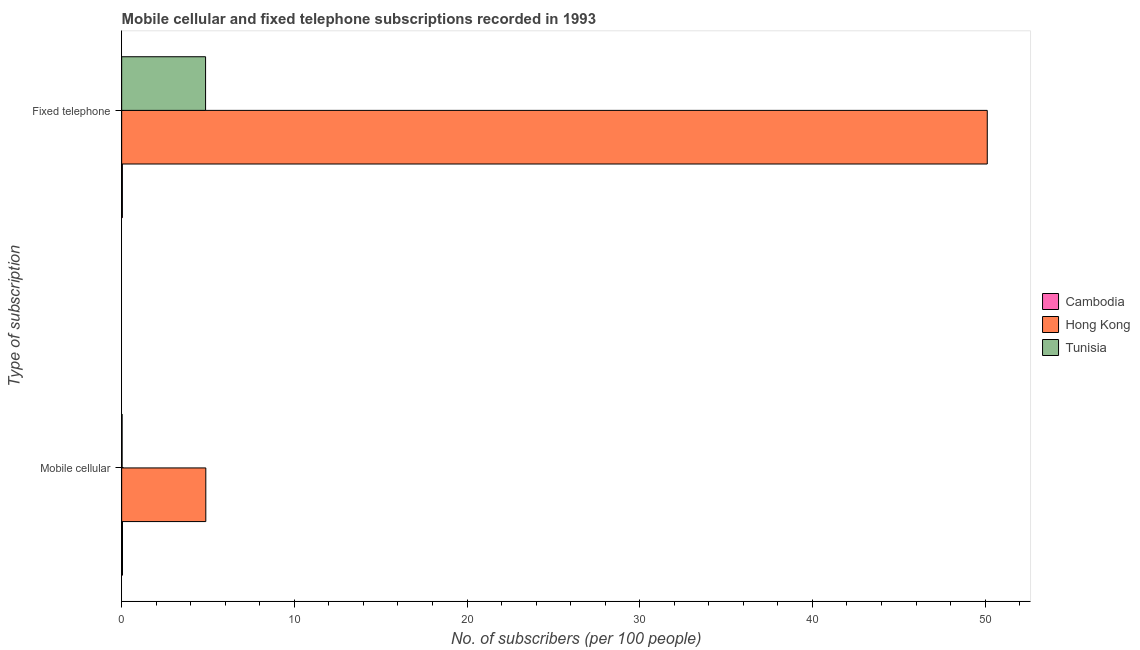How many different coloured bars are there?
Offer a terse response. 3. How many groups of bars are there?
Provide a short and direct response. 2. Are the number of bars per tick equal to the number of legend labels?
Make the answer very short. Yes. Are the number of bars on each tick of the Y-axis equal?
Offer a terse response. Yes. What is the label of the 2nd group of bars from the top?
Give a very brief answer. Mobile cellular. What is the number of mobile cellular subscribers in Hong Kong?
Give a very brief answer. 4.87. Across all countries, what is the maximum number of fixed telephone subscribers?
Keep it short and to the point. 50.12. Across all countries, what is the minimum number of fixed telephone subscribers?
Keep it short and to the point. 0.04. In which country was the number of fixed telephone subscribers maximum?
Ensure brevity in your answer.  Hong Kong. In which country was the number of mobile cellular subscribers minimum?
Keep it short and to the point. Tunisia. What is the total number of fixed telephone subscribers in the graph?
Offer a terse response. 55.02. What is the difference between the number of mobile cellular subscribers in Hong Kong and that in Cambodia?
Provide a short and direct response. 4.82. What is the difference between the number of fixed telephone subscribers in Cambodia and the number of mobile cellular subscribers in Tunisia?
Your answer should be compact. 0.02. What is the average number of fixed telephone subscribers per country?
Your answer should be very brief. 18.34. What is the difference between the number of fixed telephone subscribers and number of mobile cellular subscribers in Hong Kong?
Keep it short and to the point. 45.25. In how many countries, is the number of mobile cellular subscribers greater than 18 ?
Your answer should be very brief. 0. What is the ratio of the number of fixed telephone subscribers in Hong Kong to that in Tunisia?
Offer a very short reply. 10.32. Is the number of fixed telephone subscribers in Cambodia less than that in Hong Kong?
Offer a terse response. Yes. In how many countries, is the number of mobile cellular subscribers greater than the average number of mobile cellular subscribers taken over all countries?
Ensure brevity in your answer.  1. What does the 1st bar from the top in Mobile cellular represents?
Ensure brevity in your answer.  Tunisia. What does the 2nd bar from the bottom in Mobile cellular represents?
Give a very brief answer. Hong Kong. Are all the bars in the graph horizontal?
Keep it short and to the point. Yes. What is the difference between two consecutive major ticks on the X-axis?
Keep it short and to the point. 10. Does the graph contain grids?
Your answer should be compact. No. How are the legend labels stacked?
Provide a succinct answer. Vertical. What is the title of the graph?
Provide a short and direct response. Mobile cellular and fixed telephone subscriptions recorded in 1993. Does "Kiribati" appear as one of the legend labels in the graph?
Your answer should be compact. No. What is the label or title of the X-axis?
Keep it short and to the point. No. of subscribers (per 100 people). What is the label or title of the Y-axis?
Keep it short and to the point. Type of subscription. What is the No. of subscribers (per 100 people) in Cambodia in Mobile cellular?
Give a very brief answer. 0.05. What is the No. of subscribers (per 100 people) of Hong Kong in Mobile cellular?
Keep it short and to the point. 4.87. What is the No. of subscribers (per 100 people) of Tunisia in Mobile cellular?
Offer a terse response. 0.03. What is the No. of subscribers (per 100 people) in Cambodia in Fixed telephone?
Provide a short and direct response. 0.04. What is the No. of subscribers (per 100 people) of Hong Kong in Fixed telephone?
Keep it short and to the point. 50.12. What is the No. of subscribers (per 100 people) in Tunisia in Fixed telephone?
Keep it short and to the point. 4.86. Across all Type of subscription, what is the maximum No. of subscribers (per 100 people) in Cambodia?
Give a very brief answer. 0.05. Across all Type of subscription, what is the maximum No. of subscribers (per 100 people) of Hong Kong?
Provide a succinct answer. 50.12. Across all Type of subscription, what is the maximum No. of subscribers (per 100 people) in Tunisia?
Provide a succinct answer. 4.86. Across all Type of subscription, what is the minimum No. of subscribers (per 100 people) of Cambodia?
Provide a short and direct response. 0.04. Across all Type of subscription, what is the minimum No. of subscribers (per 100 people) in Hong Kong?
Offer a terse response. 4.87. Across all Type of subscription, what is the minimum No. of subscribers (per 100 people) of Tunisia?
Provide a succinct answer. 0.03. What is the total No. of subscribers (per 100 people) of Cambodia in the graph?
Offer a terse response. 0.09. What is the total No. of subscribers (per 100 people) of Hong Kong in the graph?
Your answer should be very brief. 55. What is the total No. of subscribers (per 100 people) in Tunisia in the graph?
Keep it short and to the point. 4.88. What is the difference between the No. of subscribers (per 100 people) of Cambodia in Mobile cellular and that in Fixed telephone?
Offer a terse response. 0.01. What is the difference between the No. of subscribers (per 100 people) in Hong Kong in Mobile cellular and that in Fixed telephone?
Provide a succinct answer. -45.25. What is the difference between the No. of subscribers (per 100 people) of Tunisia in Mobile cellular and that in Fixed telephone?
Give a very brief answer. -4.83. What is the difference between the No. of subscribers (per 100 people) of Cambodia in Mobile cellular and the No. of subscribers (per 100 people) of Hong Kong in Fixed telephone?
Keep it short and to the point. -50.08. What is the difference between the No. of subscribers (per 100 people) of Cambodia in Mobile cellular and the No. of subscribers (per 100 people) of Tunisia in Fixed telephone?
Provide a succinct answer. -4.81. What is the difference between the No. of subscribers (per 100 people) of Hong Kong in Mobile cellular and the No. of subscribers (per 100 people) of Tunisia in Fixed telephone?
Offer a terse response. 0.01. What is the average No. of subscribers (per 100 people) in Cambodia per Type of subscription?
Provide a succinct answer. 0.04. What is the average No. of subscribers (per 100 people) in Hong Kong per Type of subscription?
Make the answer very short. 27.5. What is the average No. of subscribers (per 100 people) in Tunisia per Type of subscription?
Your response must be concise. 2.44. What is the difference between the No. of subscribers (per 100 people) of Cambodia and No. of subscribers (per 100 people) of Hong Kong in Mobile cellular?
Give a very brief answer. -4.82. What is the difference between the No. of subscribers (per 100 people) in Cambodia and No. of subscribers (per 100 people) in Tunisia in Mobile cellular?
Make the answer very short. 0.02. What is the difference between the No. of subscribers (per 100 people) of Hong Kong and No. of subscribers (per 100 people) of Tunisia in Mobile cellular?
Provide a succinct answer. 4.85. What is the difference between the No. of subscribers (per 100 people) in Cambodia and No. of subscribers (per 100 people) in Hong Kong in Fixed telephone?
Provide a short and direct response. -50.08. What is the difference between the No. of subscribers (per 100 people) of Cambodia and No. of subscribers (per 100 people) of Tunisia in Fixed telephone?
Provide a succinct answer. -4.82. What is the difference between the No. of subscribers (per 100 people) in Hong Kong and No. of subscribers (per 100 people) in Tunisia in Fixed telephone?
Offer a terse response. 45.26. What is the ratio of the No. of subscribers (per 100 people) of Cambodia in Mobile cellular to that in Fixed telephone?
Offer a terse response. 1.14. What is the ratio of the No. of subscribers (per 100 people) in Hong Kong in Mobile cellular to that in Fixed telephone?
Ensure brevity in your answer.  0.1. What is the ratio of the No. of subscribers (per 100 people) in Tunisia in Mobile cellular to that in Fixed telephone?
Keep it short and to the point. 0.01. What is the difference between the highest and the second highest No. of subscribers (per 100 people) in Cambodia?
Your response must be concise. 0.01. What is the difference between the highest and the second highest No. of subscribers (per 100 people) in Hong Kong?
Provide a short and direct response. 45.25. What is the difference between the highest and the second highest No. of subscribers (per 100 people) of Tunisia?
Give a very brief answer. 4.83. What is the difference between the highest and the lowest No. of subscribers (per 100 people) of Cambodia?
Ensure brevity in your answer.  0.01. What is the difference between the highest and the lowest No. of subscribers (per 100 people) of Hong Kong?
Make the answer very short. 45.25. What is the difference between the highest and the lowest No. of subscribers (per 100 people) of Tunisia?
Your answer should be very brief. 4.83. 